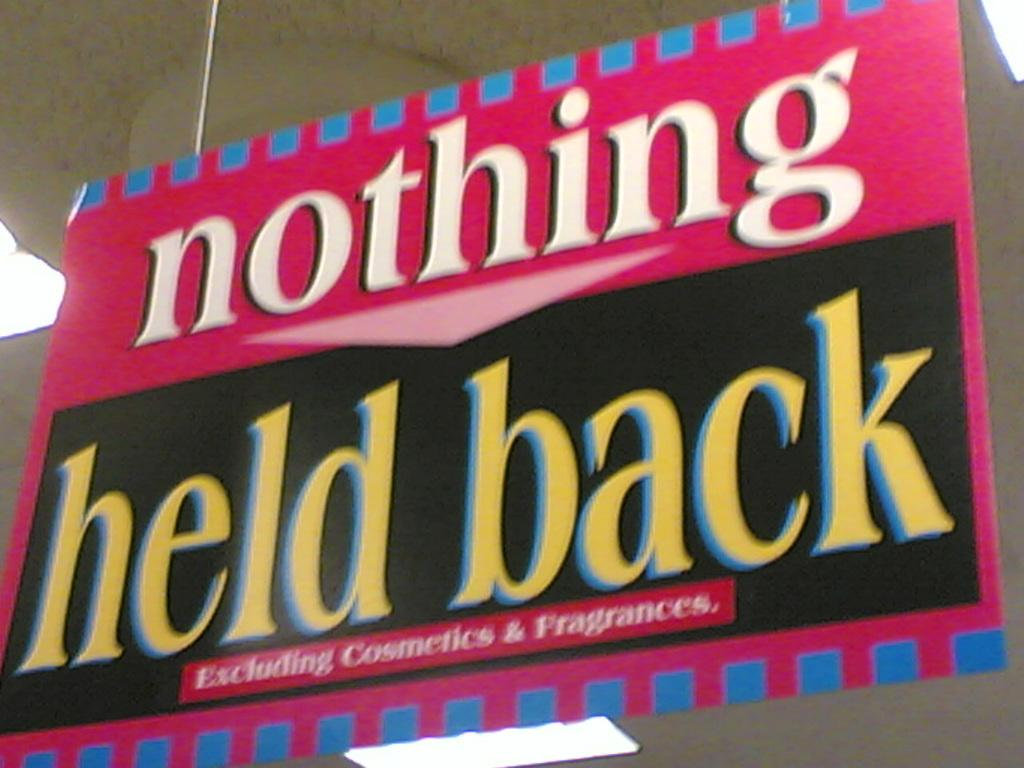<image>
Render a clear and concise summary of the photo. Nothing held back excluding cosmetics and fragrances pink banner. 